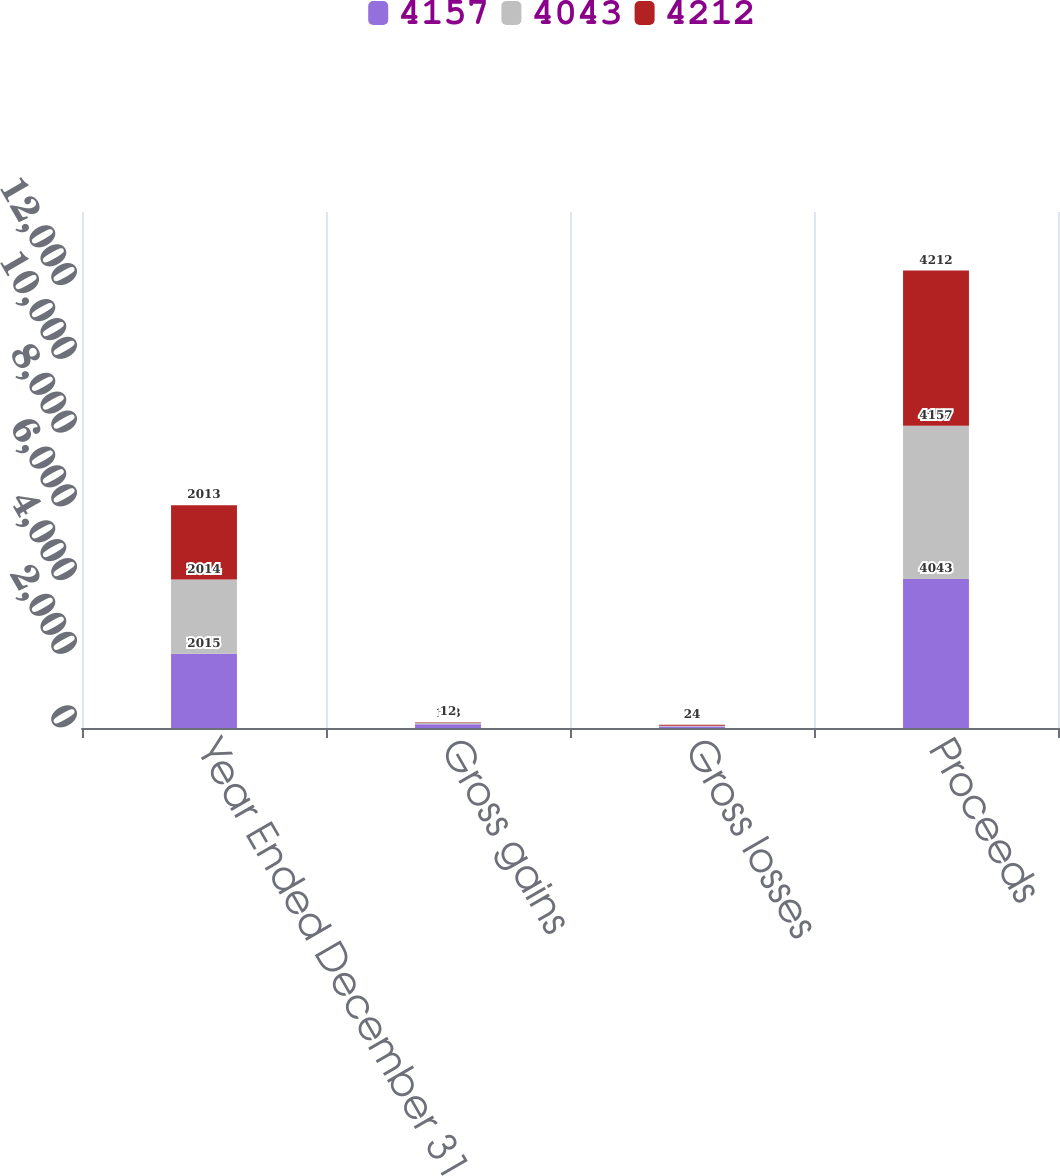Convert chart to OTSL. <chart><loc_0><loc_0><loc_500><loc_500><stacked_bar_chart><ecel><fcel>Year Ended December 31<fcel>Gross gains<fcel>Gross losses<fcel>Proceeds<nl><fcel>4157<fcel>2015<fcel>103<fcel>42<fcel>4043<nl><fcel>4043<fcel>2014<fcel>38<fcel>21<fcel>4157<nl><fcel>4212<fcel>2013<fcel>12<fcel>24<fcel>4212<nl></chart> 